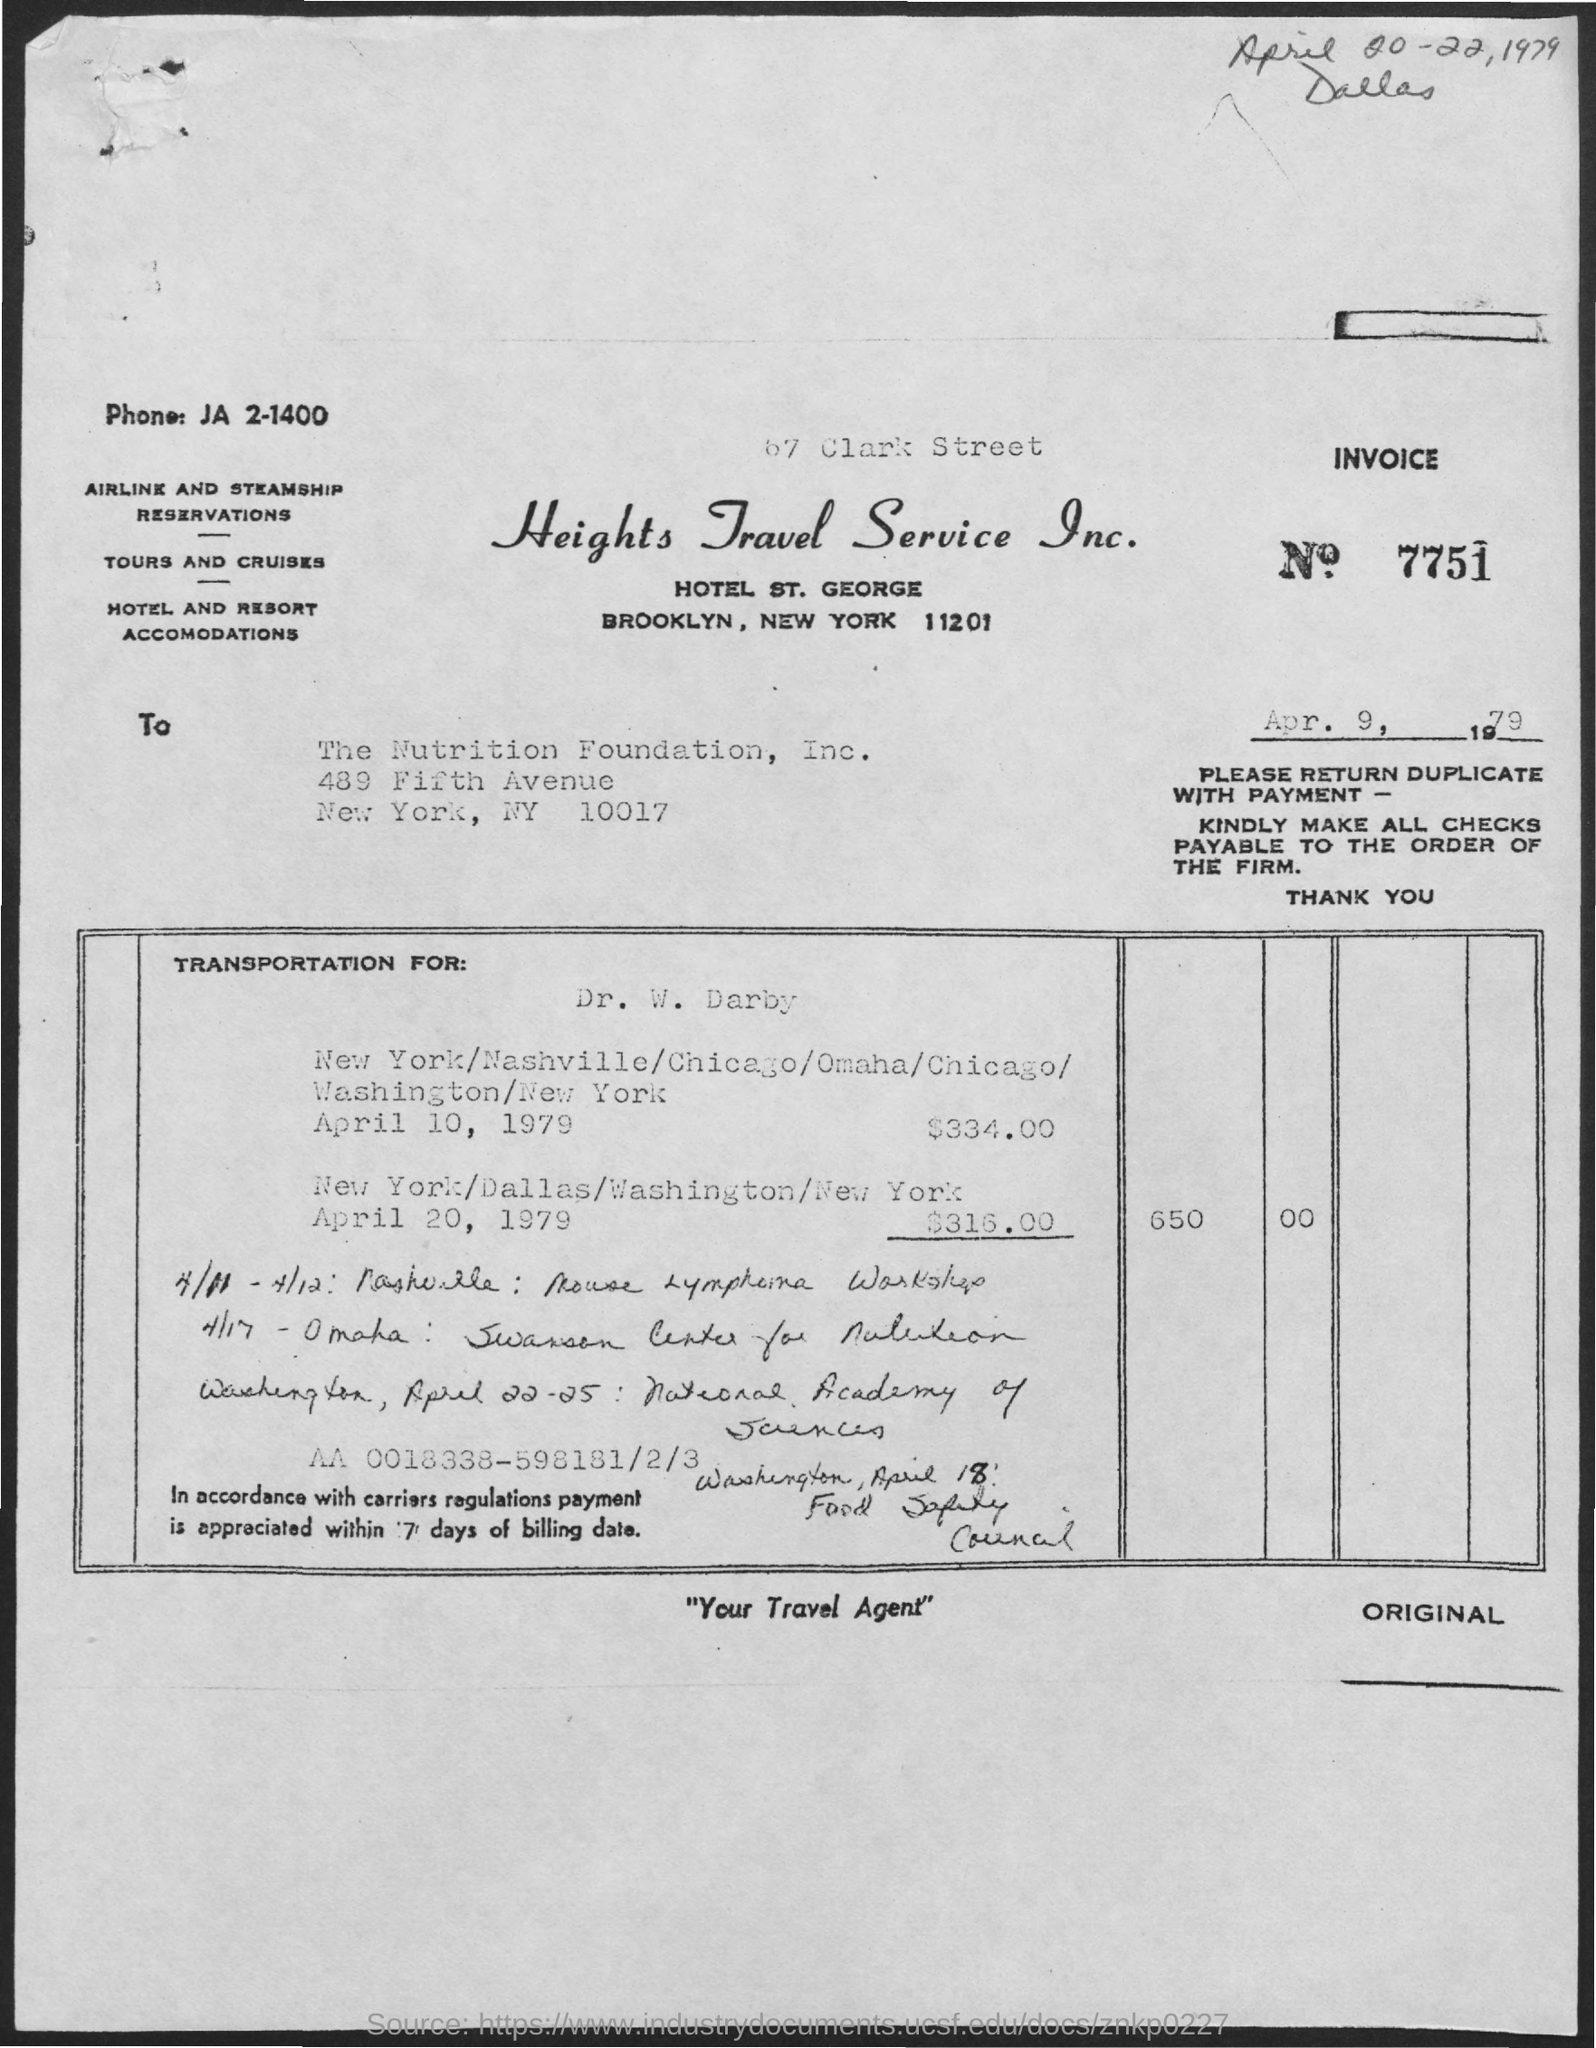Mention a couple of crucial points in this snapshot. Your Travel Agent" is the tagline of Heights Travel Service Inc. Please provide the invoice number, which is 7751. 